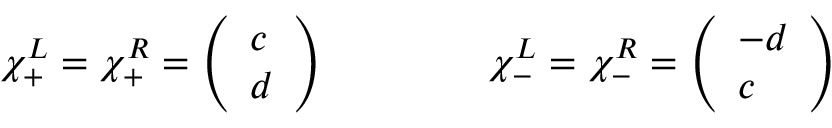Convert formula to latex. <formula><loc_0><loc_0><loc_500><loc_500>\chi _ { + } ^ { L } = \chi _ { + } ^ { R } = \left ( \begin{array} { l } { c } \\ { d } \end{array} \right ) \quad \chi _ { - } ^ { L } = \chi _ { - } ^ { R } = \left ( \begin{array} { l } { - d } \\ { c } \end{array} \right )</formula> 